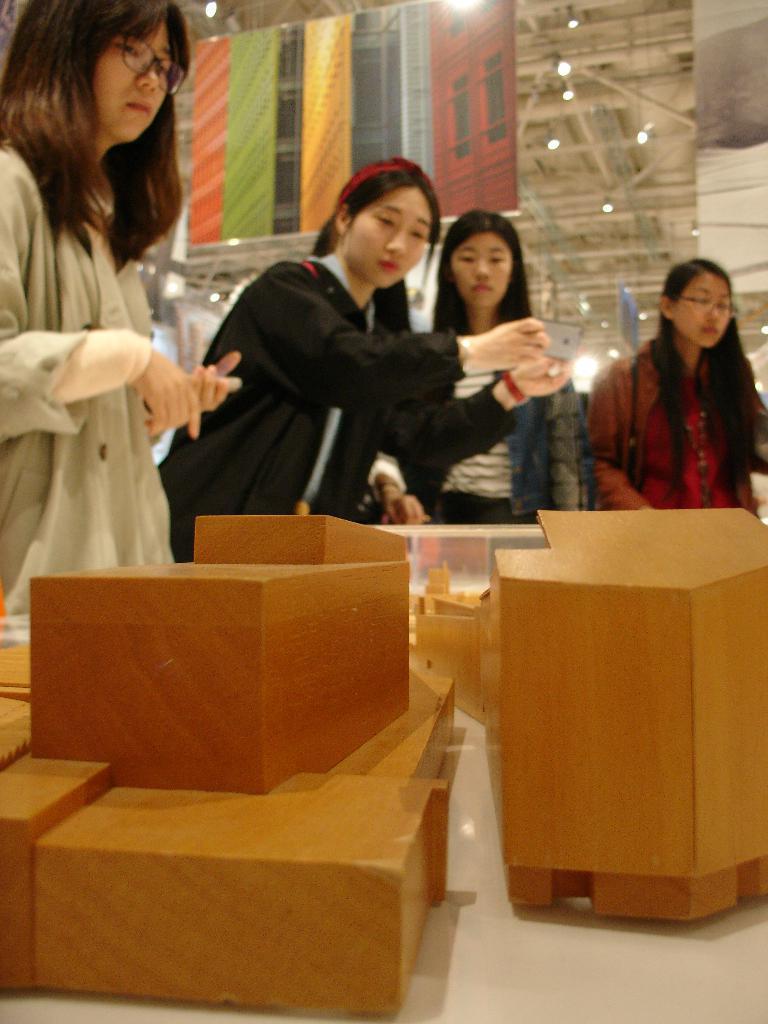Can you describe this image briefly? In this image there are women standing. Bottom of the image there is a table having wooden objects. Middle of the image there is a woman holding a mobile in her hand. There are lights attached to the roof. There are banners hanging from the roof. 